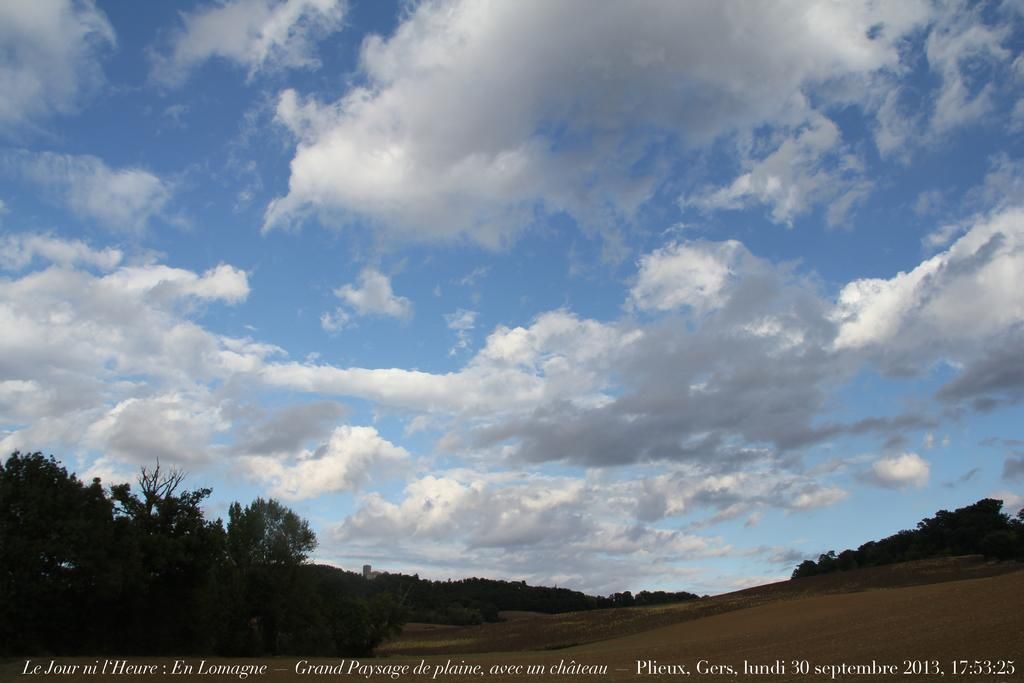What type of vegetation is present on the land in the image? There are trees on the land in the image. What is visible at the top of the image? The sky is visible at the top of the image. What can be seen in the sky in the image? There are clouds in the sky. What is the weight of the milk in the image? There is no milk present in the image, so it is not possible to determine its weight. 